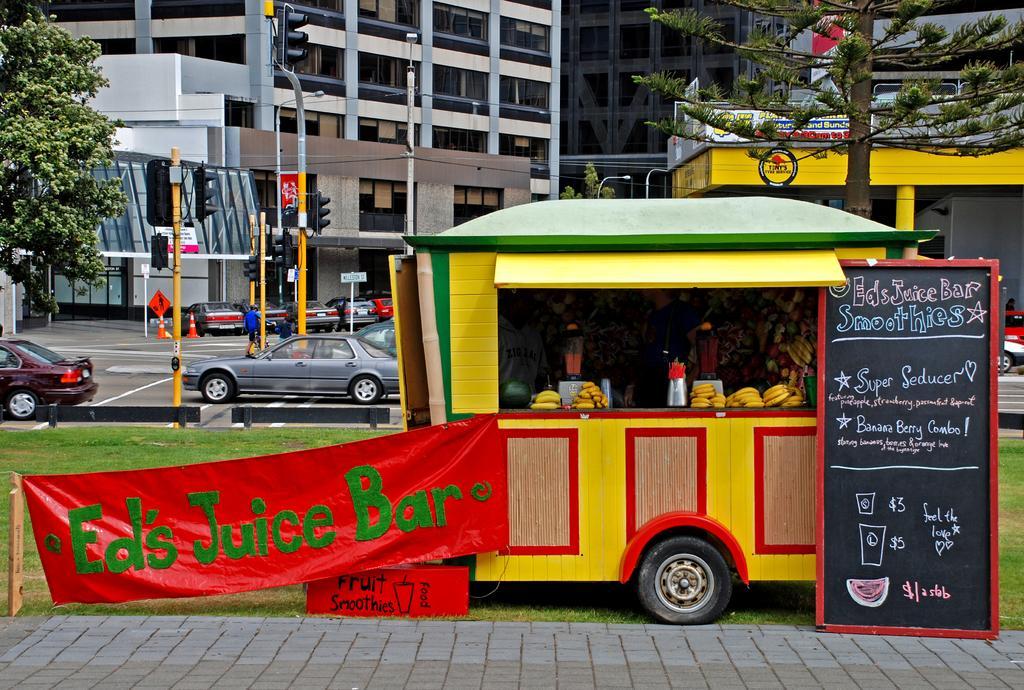Describe this image in one or two sentences. This image is taken outdoors. At the bottom of the image there is a sidewalk and there is a ground with grass on it. In the middle of the image there is a food truck with many food items. There is a board with a text on it and there is a banner with a text on it. In the background there are a few buildings, poles with street lights and signal lights and there are two trees. A few vehicles are moving on the road and a few are parked on the road. There is a signboard and a man is walking on the road. 